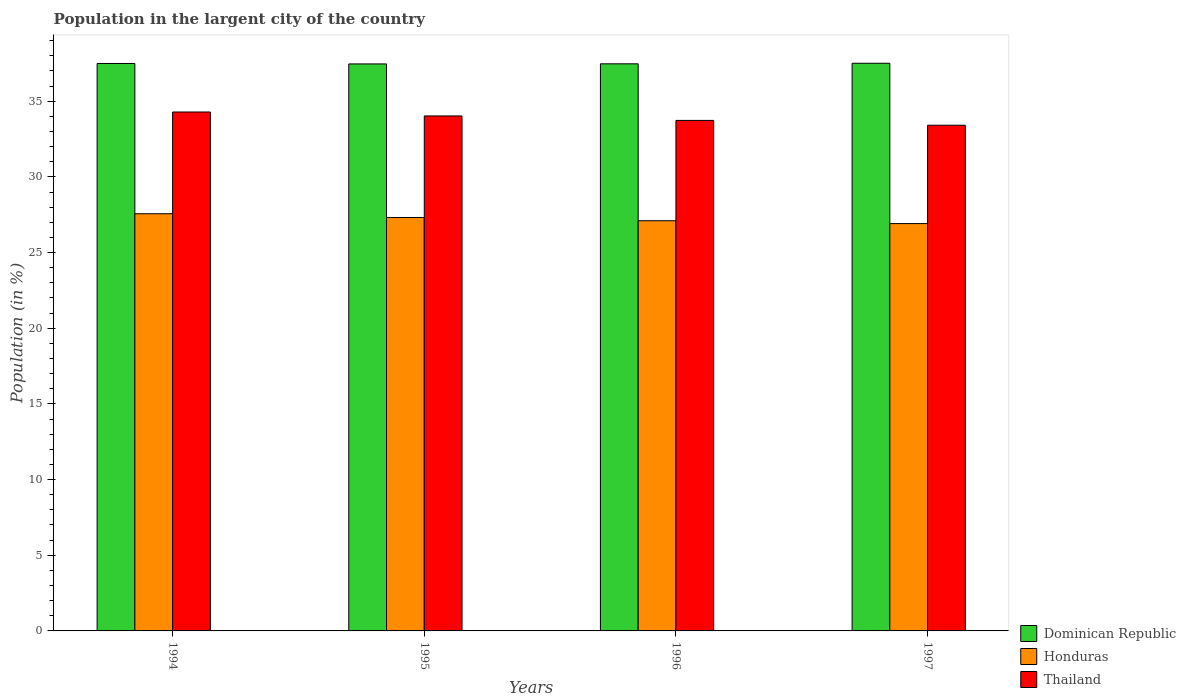How many different coloured bars are there?
Give a very brief answer. 3. How many bars are there on the 2nd tick from the right?
Give a very brief answer. 3. What is the label of the 4th group of bars from the left?
Keep it short and to the point. 1997. In how many cases, is the number of bars for a given year not equal to the number of legend labels?
Offer a terse response. 0. What is the percentage of population in the largent city in Thailand in 1994?
Give a very brief answer. 34.29. Across all years, what is the maximum percentage of population in the largent city in Honduras?
Offer a terse response. 27.57. Across all years, what is the minimum percentage of population in the largent city in Honduras?
Your response must be concise. 26.92. What is the total percentage of population in the largent city in Honduras in the graph?
Provide a short and direct response. 108.9. What is the difference between the percentage of population in the largent city in Dominican Republic in 1995 and that in 1996?
Offer a very short reply. -0.01. What is the difference between the percentage of population in the largent city in Dominican Republic in 1996 and the percentage of population in the largent city in Honduras in 1994?
Your answer should be compact. 9.91. What is the average percentage of population in the largent city in Honduras per year?
Provide a succinct answer. 27.23. In the year 1995, what is the difference between the percentage of population in the largent city in Dominican Republic and percentage of population in the largent city in Thailand?
Offer a very short reply. 3.44. What is the ratio of the percentage of population in the largent city in Honduras in 1995 to that in 1996?
Make the answer very short. 1.01. Is the percentage of population in the largent city in Honduras in 1994 less than that in 1997?
Your answer should be compact. No. Is the difference between the percentage of population in the largent city in Dominican Republic in 1994 and 1997 greater than the difference between the percentage of population in the largent city in Thailand in 1994 and 1997?
Ensure brevity in your answer.  No. What is the difference between the highest and the second highest percentage of population in the largent city in Dominican Republic?
Keep it short and to the point. 0.02. What is the difference between the highest and the lowest percentage of population in the largent city in Thailand?
Provide a succinct answer. 0.87. What does the 2nd bar from the left in 1996 represents?
Your response must be concise. Honduras. What does the 1st bar from the right in 1996 represents?
Your response must be concise. Thailand. How many bars are there?
Offer a terse response. 12. What is the difference between two consecutive major ticks on the Y-axis?
Your response must be concise. 5. Are the values on the major ticks of Y-axis written in scientific E-notation?
Your response must be concise. No. Does the graph contain any zero values?
Provide a short and direct response. No. Does the graph contain grids?
Provide a succinct answer. No. Where does the legend appear in the graph?
Provide a short and direct response. Bottom right. How are the legend labels stacked?
Provide a short and direct response. Vertical. What is the title of the graph?
Your answer should be compact. Population in the largent city of the country. Does "China" appear as one of the legend labels in the graph?
Your answer should be very brief. No. What is the label or title of the X-axis?
Provide a short and direct response. Years. What is the label or title of the Y-axis?
Offer a very short reply. Population (in %). What is the Population (in %) of Dominican Republic in 1994?
Offer a terse response. 37.49. What is the Population (in %) of Honduras in 1994?
Provide a short and direct response. 27.57. What is the Population (in %) in Thailand in 1994?
Provide a short and direct response. 34.29. What is the Population (in %) of Dominican Republic in 1995?
Ensure brevity in your answer.  37.47. What is the Population (in %) in Honduras in 1995?
Your answer should be very brief. 27.32. What is the Population (in %) in Thailand in 1995?
Make the answer very short. 34.03. What is the Population (in %) of Dominican Republic in 1996?
Your answer should be compact. 37.47. What is the Population (in %) in Honduras in 1996?
Your answer should be compact. 27.1. What is the Population (in %) of Thailand in 1996?
Your answer should be very brief. 33.73. What is the Population (in %) of Dominican Republic in 1997?
Ensure brevity in your answer.  37.51. What is the Population (in %) in Honduras in 1997?
Offer a very short reply. 26.92. What is the Population (in %) in Thailand in 1997?
Give a very brief answer. 33.42. Across all years, what is the maximum Population (in %) of Dominican Republic?
Offer a very short reply. 37.51. Across all years, what is the maximum Population (in %) in Honduras?
Provide a succinct answer. 27.57. Across all years, what is the maximum Population (in %) in Thailand?
Give a very brief answer. 34.29. Across all years, what is the minimum Population (in %) of Dominican Republic?
Keep it short and to the point. 37.47. Across all years, what is the minimum Population (in %) of Honduras?
Make the answer very short. 26.92. Across all years, what is the minimum Population (in %) of Thailand?
Make the answer very short. 33.42. What is the total Population (in %) of Dominican Republic in the graph?
Provide a succinct answer. 149.94. What is the total Population (in %) of Honduras in the graph?
Keep it short and to the point. 108.9. What is the total Population (in %) in Thailand in the graph?
Provide a succinct answer. 135.47. What is the difference between the Population (in %) in Dominican Republic in 1994 and that in 1995?
Your answer should be compact. 0.03. What is the difference between the Population (in %) of Honduras in 1994 and that in 1995?
Keep it short and to the point. 0.25. What is the difference between the Population (in %) in Thailand in 1994 and that in 1995?
Offer a very short reply. 0.26. What is the difference between the Population (in %) in Dominican Republic in 1994 and that in 1996?
Offer a very short reply. 0.02. What is the difference between the Population (in %) in Honduras in 1994 and that in 1996?
Your answer should be compact. 0.46. What is the difference between the Population (in %) in Thailand in 1994 and that in 1996?
Provide a short and direct response. 0.56. What is the difference between the Population (in %) of Dominican Republic in 1994 and that in 1997?
Provide a succinct answer. -0.02. What is the difference between the Population (in %) in Honduras in 1994 and that in 1997?
Keep it short and to the point. 0.65. What is the difference between the Population (in %) of Thailand in 1994 and that in 1997?
Offer a very short reply. 0.87. What is the difference between the Population (in %) in Dominican Republic in 1995 and that in 1996?
Your response must be concise. -0.01. What is the difference between the Population (in %) of Honduras in 1995 and that in 1996?
Your answer should be very brief. 0.22. What is the difference between the Population (in %) of Thailand in 1995 and that in 1996?
Your answer should be compact. 0.3. What is the difference between the Population (in %) in Dominican Republic in 1995 and that in 1997?
Give a very brief answer. -0.04. What is the difference between the Population (in %) of Honduras in 1995 and that in 1997?
Ensure brevity in your answer.  0.4. What is the difference between the Population (in %) of Thailand in 1995 and that in 1997?
Give a very brief answer. 0.61. What is the difference between the Population (in %) in Dominican Republic in 1996 and that in 1997?
Make the answer very short. -0.04. What is the difference between the Population (in %) of Honduras in 1996 and that in 1997?
Make the answer very short. 0.19. What is the difference between the Population (in %) in Thailand in 1996 and that in 1997?
Keep it short and to the point. 0.32. What is the difference between the Population (in %) of Dominican Republic in 1994 and the Population (in %) of Honduras in 1995?
Offer a terse response. 10.18. What is the difference between the Population (in %) of Dominican Republic in 1994 and the Population (in %) of Thailand in 1995?
Ensure brevity in your answer.  3.47. What is the difference between the Population (in %) in Honduras in 1994 and the Population (in %) in Thailand in 1995?
Make the answer very short. -6.46. What is the difference between the Population (in %) in Dominican Republic in 1994 and the Population (in %) in Honduras in 1996?
Your answer should be very brief. 10.39. What is the difference between the Population (in %) of Dominican Republic in 1994 and the Population (in %) of Thailand in 1996?
Your response must be concise. 3.76. What is the difference between the Population (in %) of Honduras in 1994 and the Population (in %) of Thailand in 1996?
Give a very brief answer. -6.17. What is the difference between the Population (in %) in Dominican Republic in 1994 and the Population (in %) in Honduras in 1997?
Offer a very short reply. 10.58. What is the difference between the Population (in %) of Dominican Republic in 1994 and the Population (in %) of Thailand in 1997?
Offer a terse response. 4.08. What is the difference between the Population (in %) of Honduras in 1994 and the Population (in %) of Thailand in 1997?
Your answer should be very brief. -5.85. What is the difference between the Population (in %) in Dominican Republic in 1995 and the Population (in %) in Honduras in 1996?
Make the answer very short. 10.36. What is the difference between the Population (in %) in Dominican Republic in 1995 and the Population (in %) in Thailand in 1996?
Offer a very short reply. 3.73. What is the difference between the Population (in %) in Honduras in 1995 and the Population (in %) in Thailand in 1996?
Offer a terse response. -6.41. What is the difference between the Population (in %) of Dominican Republic in 1995 and the Population (in %) of Honduras in 1997?
Your answer should be very brief. 10.55. What is the difference between the Population (in %) in Dominican Republic in 1995 and the Population (in %) in Thailand in 1997?
Make the answer very short. 4.05. What is the difference between the Population (in %) in Honduras in 1995 and the Population (in %) in Thailand in 1997?
Give a very brief answer. -6.1. What is the difference between the Population (in %) of Dominican Republic in 1996 and the Population (in %) of Honduras in 1997?
Your answer should be very brief. 10.56. What is the difference between the Population (in %) of Dominican Republic in 1996 and the Population (in %) of Thailand in 1997?
Make the answer very short. 4.06. What is the difference between the Population (in %) in Honduras in 1996 and the Population (in %) in Thailand in 1997?
Make the answer very short. -6.31. What is the average Population (in %) in Dominican Republic per year?
Ensure brevity in your answer.  37.49. What is the average Population (in %) in Honduras per year?
Keep it short and to the point. 27.23. What is the average Population (in %) of Thailand per year?
Provide a succinct answer. 33.87. In the year 1994, what is the difference between the Population (in %) of Dominican Republic and Population (in %) of Honduras?
Your response must be concise. 9.93. In the year 1994, what is the difference between the Population (in %) in Dominican Republic and Population (in %) in Thailand?
Ensure brevity in your answer.  3.21. In the year 1994, what is the difference between the Population (in %) of Honduras and Population (in %) of Thailand?
Provide a short and direct response. -6.72. In the year 1995, what is the difference between the Population (in %) in Dominican Republic and Population (in %) in Honduras?
Your answer should be compact. 10.15. In the year 1995, what is the difference between the Population (in %) of Dominican Republic and Population (in %) of Thailand?
Give a very brief answer. 3.44. In the year 1995, what is the difference between the Population (in %) in Honduras and Population (in %) in Thailand?
Give a very brief answer. -6.71. In the year 1996, what is the difference between the Population (in %) of Dominican Republic and Population (in %) of Honduras?
Your response must be concise. 10.37. In the year 1996, what is the difference between the Population (in %) in Dominican Republic and Population (in %) in Thailand?
Provide a succinct answer. 3.74. In the year 1996, what is the difference between the Population (in %) in Honduras and Population (in %) in Thailand?
Give a very brief answer. -6.63. In the year 1997, what is the difference between the Population (in %) of Dominican Republic and Population (in %) of Honduras?
Provide a succinct answer. 10.59. In the year 1997, what is the difference between the Population (in %) of Dominican Republic and Population (in %) of Thailand?
Offer a very short reply. 4.09. In the year 1997, what is the difference between the Population (in %) in Honduras and Population (in %) in Thailand?
Keep it short and to the point. -6.5. What is the ratio of the Population (in %) in Honduras in 1994 to that in 1995?
Your answer should be very brief. 1.01. What is the ratio of the Population (in %) of Thailand in 1994 to that in 1995?
Offer a terse response. 1.01. What is the ratio of the Population (in %) in Dominican Republic in 1994 to that in 1996?
Your answer should be very brief. 1. What is the ratio of the Population (in %) of Honduras in 1994 to that in 1996?
Your answer should be very brief. 1.02. What is the ratio of the Population (in %) in Thailand in 1994 to that in 1996?
Keep it short and to the point. 1.02. What is the ratio of the Population (in %) in Honduras in 1994 to that in 1997?
Your answer should be compact. 1.02. What is the ratio of the Population (in %) in Thailand in 1994 to that in 1997?
Offer a very short reply. 1.03. What is the ratio of the Population (in %) in Dominican Republic in 1995 to that in 1996?
Your answer should be compact. 1. What is the ratio of the Population (in %) of Honduras in 1995 to that in 1996?
Offer a terse response. 1.01. What is the ratio of the Population (in %) of Thailand in 1995 to that in 1996?
Your response must be concise. 1.01. What is the ratio of the Population (in %) of Dominican Republic in 1995 to that in 1997?
Offer a terse response. 1. What is the ratio of the Population (in %) in Honduras in 1995 to that in 1997?
Ensure brevity in your answer.  1.01. What is the ratio of the Population (in %) of Thailand in 1995 to that in 1997?
Provide a short and direct response. 1.02. What is the ratio of the Population (in %) of Dominican Republic in 1996 to that in 1997?
Your response must be concise. 1. What is the ratio of the Population (in %) of Thailand in 1996 to that in 1997?
Provide a short and direct response. 1.01. What is the difference between the highest and the second highest Population (in %) of Dominican Republic?
Give a very brief answer. 0.02. What is the difference between the highest and the second highest Population (in %) in Honduras?
Give a very brief answer. 0.25. What is the difference between the highest and the second highest Population (in %) of Thailand?
Ensure brevity in your answer.  0.26. What is the difference between the highest and the lowest Population (in %) in Dominican Republic?
Your response must be concise. 0.04. What is the difference between the highest and the lowest Population (in %) of Honduras?
Offer a very short reply. 0.65. What is the difference between the highest and the lowest Population (in %) in Thailand?
Give a very brief answer. 0.87. 